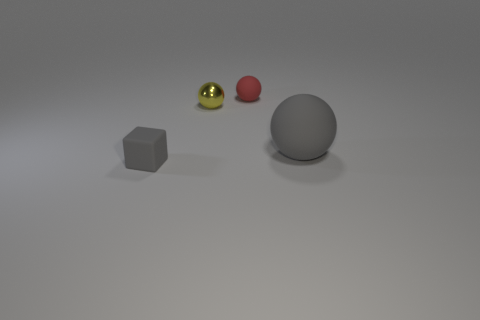Subtract all red matte spheres. How many spheres are left? 2 Add 2 green rubber blocks. How many objects exist? 6 Subtract all red balls. How many balls are left? 2 Subtract all spheres. How many objects are left? 1 Subtract 1 balls. How many balls are left? 2 Add 4 small red balls. How many small red balls are left? 5 Add 4 tiny yellow metal balls. How many tiny yellow metal balls exist? 5 Subtract 0 purple cubes. How many objects are left? 4 Subtract all brown spheres. Subtract all yellow cylinders. How many spheres are left? 3 Subtract all matte spheres. Subtract all large red rubber balls. How many objects are left? 2 